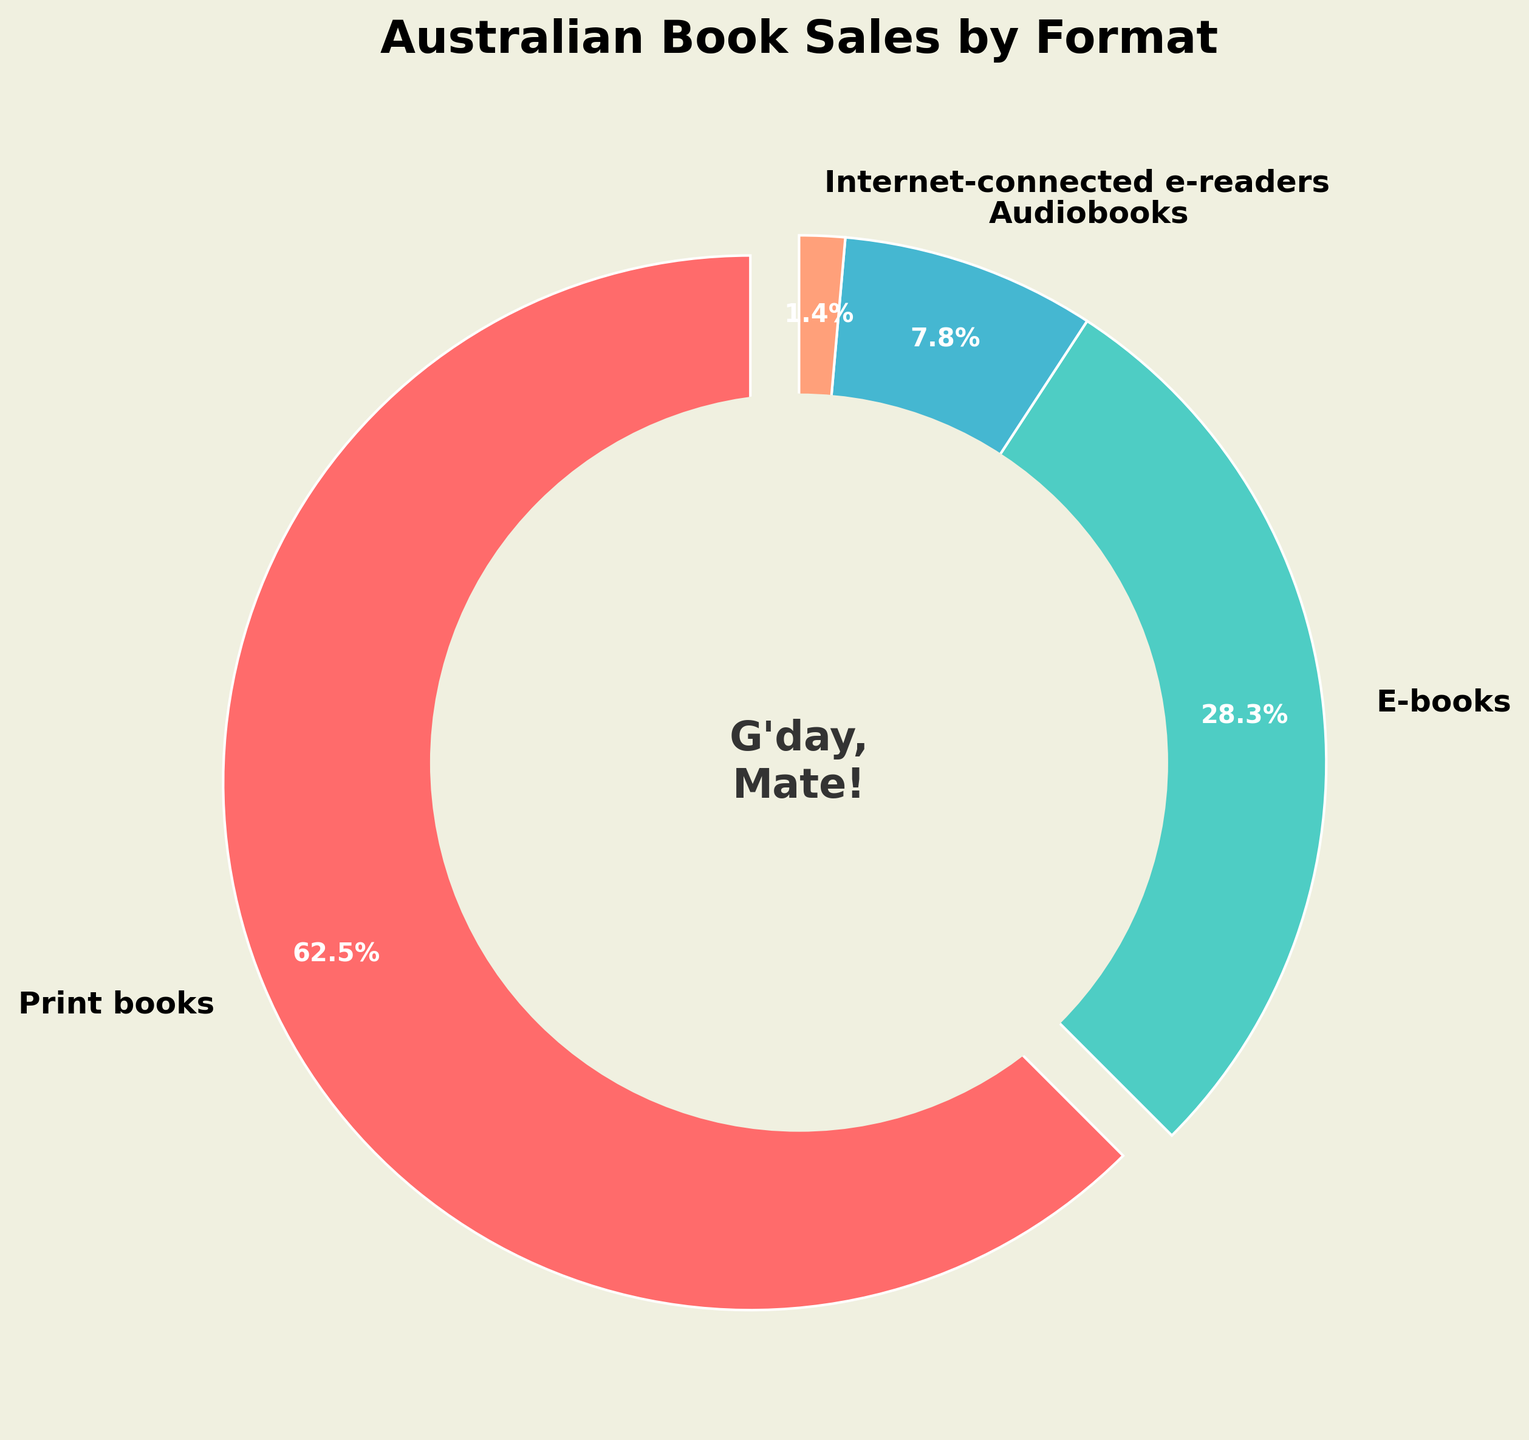What percentage of book sales are not print books? To find the percentage of book sales that are not print books, we need to add the percentages of e-books, audiobooks, and internet-connected e-readers. This is 28.3% + 7.8% + 1.4%, which equals 37.5%.
Answer: 37.5% Which format has the highest sales percentage? By looking at the figure, we see that print books have the largest section of the pie chart, indicating the highest sales percentage at 62.5%.
Answer: Print books What is the difference in sales percentage between e-books and print books? The sales percentage of print books is 62.5%, and for e-books, it’s 28.3%. Subtracting these gives us 62.5% - 28.3% = 34.2%.
Answer: 34.2% What color represents the format with the smallest percentage of sales? The smallest section in the pie chart is internet-connected e-readers, which are colored light orange.
Answer: Light orange How do sales percentages of audiobooks and internet-connected e-readers compare? Audiobooks have a sales percentage of 7.8%, whereas internet-connected e-readers have 1.4%. Audiobooks have a higher percentage.
Answer: Audiobooks have a higher percentage If print books and e-books were combined into a single category, what would their total sales percentage be? Adding the percentages of print books and e-books gives us 62.5% + 28.3%, which equals 90.8%.
Answer: 90.8% What is the visual feature at the center of the pie chart? The figure has a central circle that contains the text "G'day, Mate!" colored in a dark shade.
Answer: "G'day, Mate!" Do print books or e-books contribute more towards the total book sales? By referring to the pie chart, we can see that print books, at 62.5%, have a higher sales percentage than e-books, which are at 28.3%.
Answer: Print books What percentage more do print books sell than audiobooks? The sales percentage of print books is 62.5%, and for audiobooks, it is 7.8%. Subtracting these gives us 62.5% - 7.8% = 54.7%.
Answer: 54.7% What is the combined sales percentage of print books, e-books, and audiobooks? Adding the percentages of print books, e-books, and audiobooks gives us 62.5% + 28.3% + 7.8%, which equals 98.6%.
Answer: 98.6% 